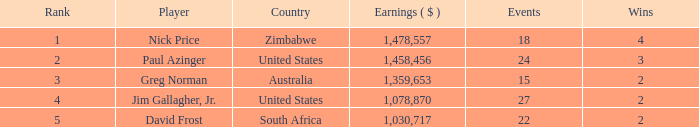How many incidents have earnings lesser than 1,030,717? 0.0. 